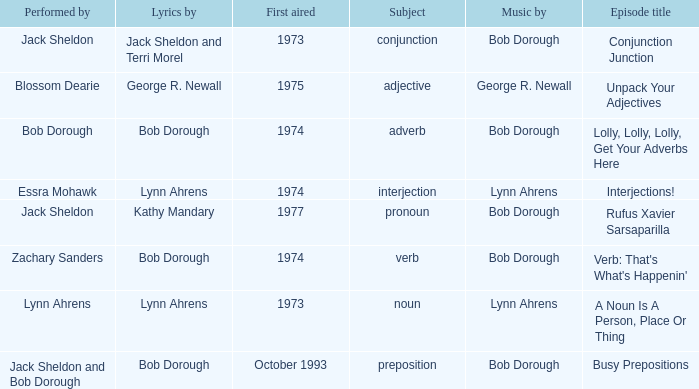When pronoun is the subject what is the episode title? Rufus Xavier Sarsaparilla. 